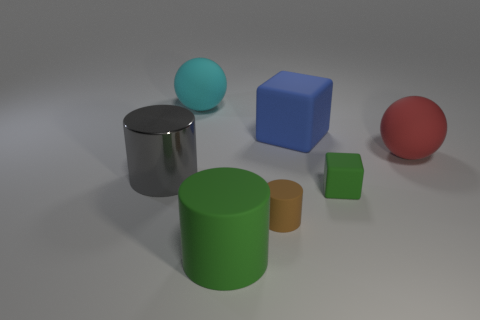Subtract all matte cylinders. How many cylinders are left? 1 Add 2 large metal cylinders. How many objects exist? 9 Subtract all blue cylinders. Subtract all gray spheres. How many cylinders are left? 3 Subtract all gray things. Subtract all small red matte things. How many objects are left? 6 Add 3 rubber cylinders. How many rubber cylinders are left? 5 Add 5 big red objects. How many big red objects exist? 6 Subtract 1 green cylinders. How many objects are left? 6 Subtract all balls. How many objects are left? 5 